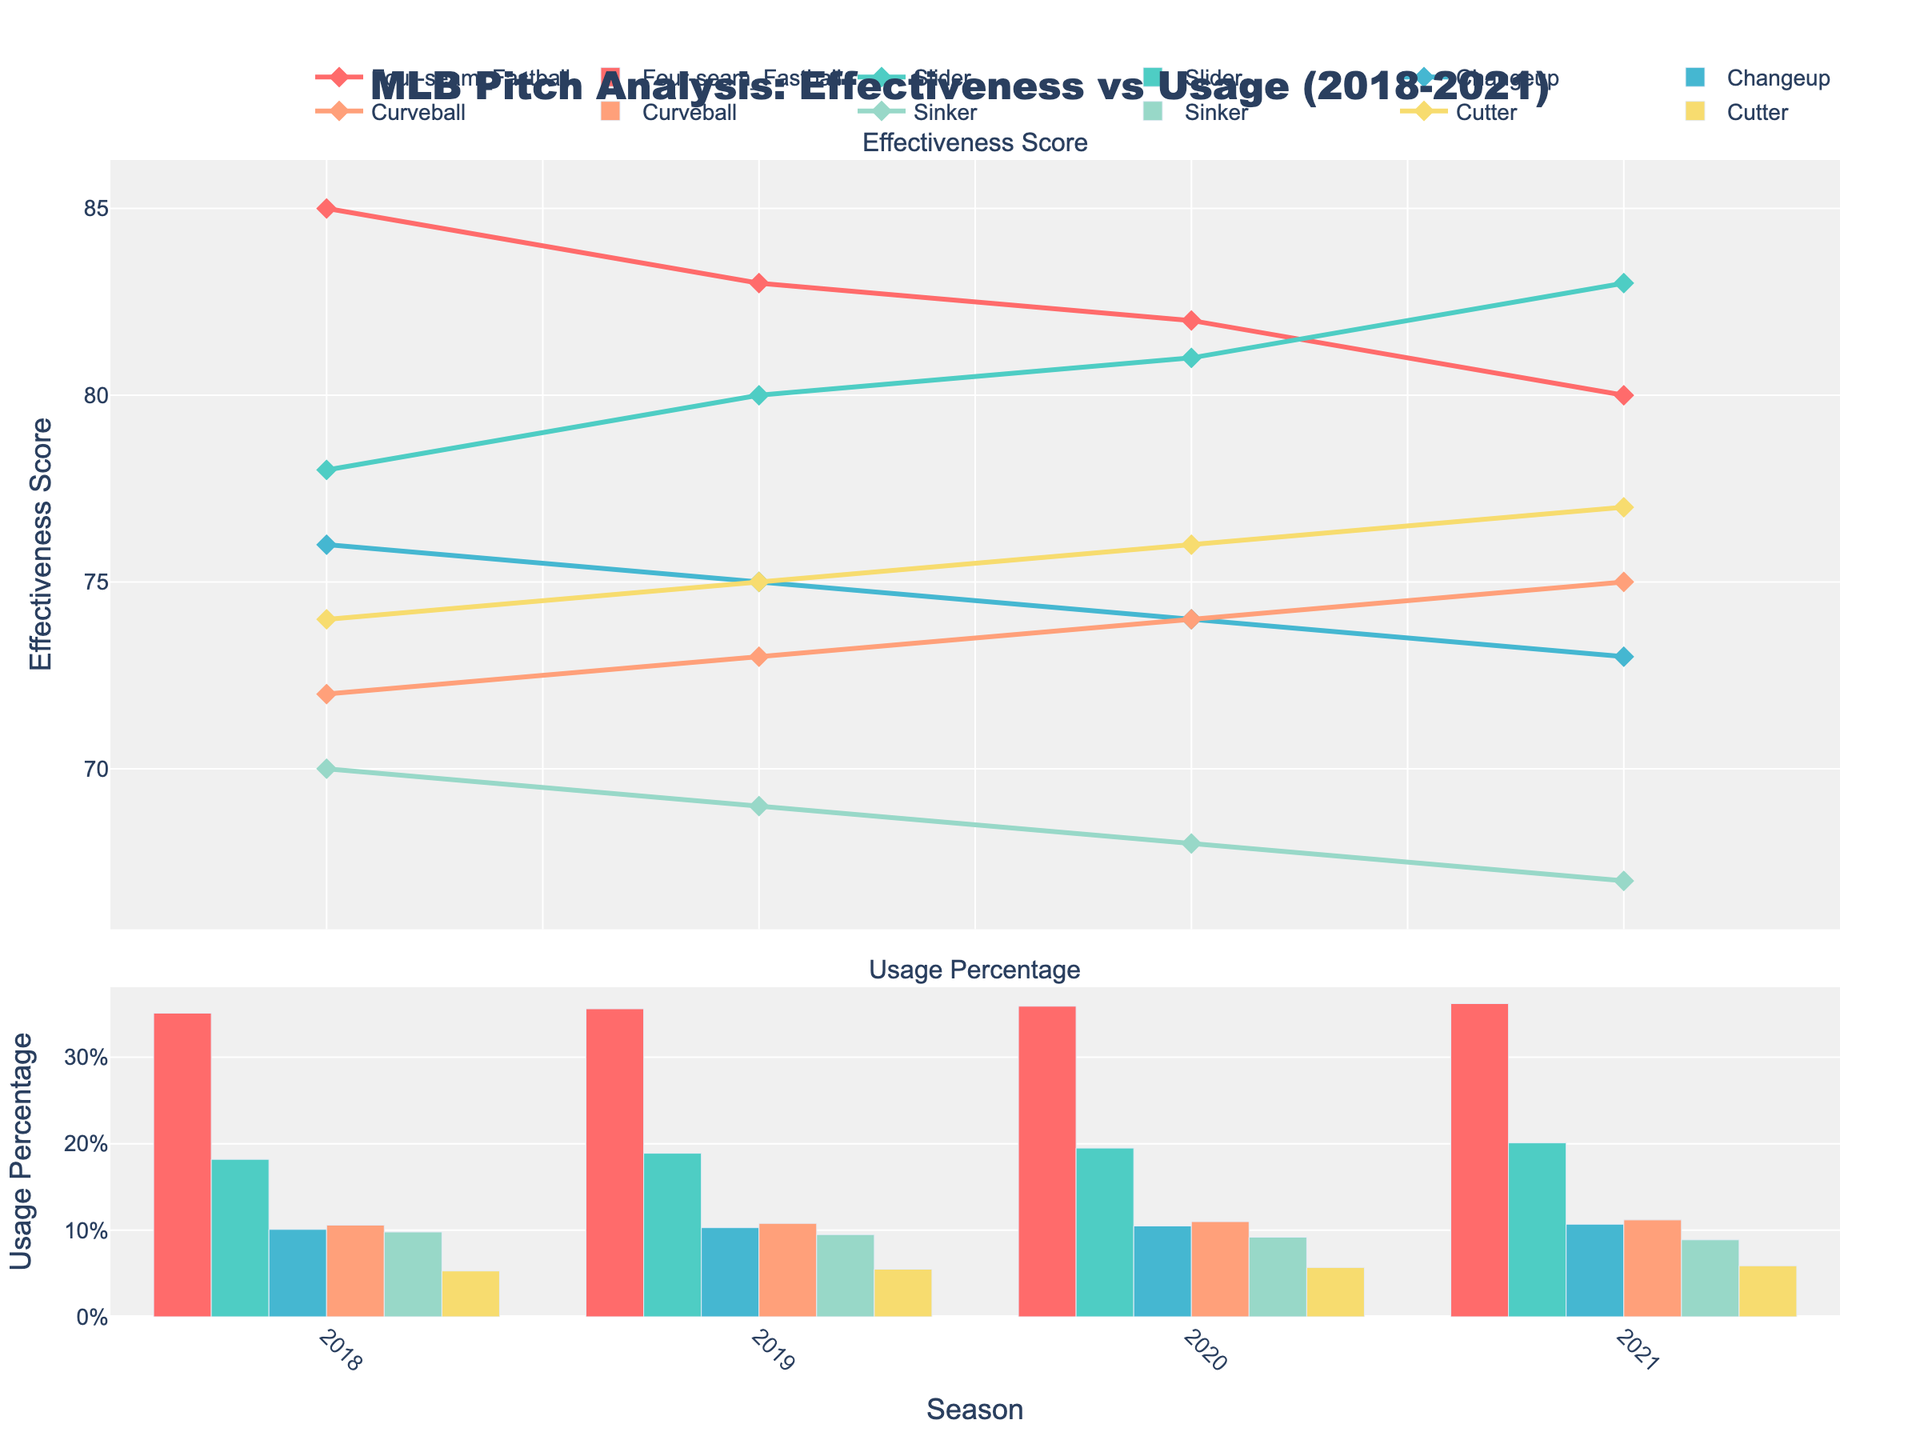Which pitch type had the highest effectiveness score in 2021? In the figure, the top plot titled "Effectiveness Score" shows various pitch types for the year 2021. By looking at the highest point, we see that the Slider has the highest effectiveness score.
Answer: Slider What was the trend in usage percentage for the Changeup from 2018 to 2021? In the "Usage Percentage" bar chart, observe the Changeup bars over the years 2018 to 2021. Notice the steady increase from 10.1% in 2018 to 10.7% in 2021.
Answer: Steady increase Which pitch type showed a consistent increase in effectiveness score from 2018 to 2021? Refer to the "Effectiveness Score" plot and trace each pitch type's line from 2018 to 2021. The Slider’s line shows a consistent increase in effectiveness score across these years.
Answer: Slider How does the effectiveness score of the Cutter in 2018 compare to its score in 2021? Check the "Effectiveness Score" plot for the Cutter’s values in 2018 and 2021. The score increases from 74 in 2018 to 77 in 2021, an increase of 3 points.
Answer: Increased by 3 points Which pitch type had the highest usage percentage in 2019? Look at the "Usage Percentage" plot for the year 2019. The pitch type with the tallest bar in 2019 is the Four-seam Fastball.
Answer: Four-seam Fastball What was the relationship between effectiveness score and usage percentage for the Sinker in 2021? Look at both the "Effectiveness Score" and "Usage Percentage" plots for the Sinker in 2021. The effectiveness score is 67, and the usage percentage is 8.9%.
Answer: Effectiveness decreased, usage decreased What is the average effectiveness score of the Four-seam Fastball across all years? To find the average, take the effectiveness scores of the Four-seam Fastball (85, 83, 82, 80) and calculate the mean: (85+83+82+80)/4 = 82.5
Answer: 82.5 Which pitch type saw the largest decrease in effectiveness score from 2018 to 2021? Identify the pitch type with the most significant drop by subtracting the 2021 score from the 2018 score for each pitch type. The Sinker decreases from 70 to 67, a drop of 3 points.
Answer: Sinker Are there any pitch types where the effectiveness score and usage percentage trends do not correlate positively from 2018 to 2021? Cross-reference both plots for each pitch type. Notice that the Four-seam Fastball's effectiveness score decreases while its usage percentage slightly increases, indicating a non-positive correlation.
Answer: Four-seam Fastball 